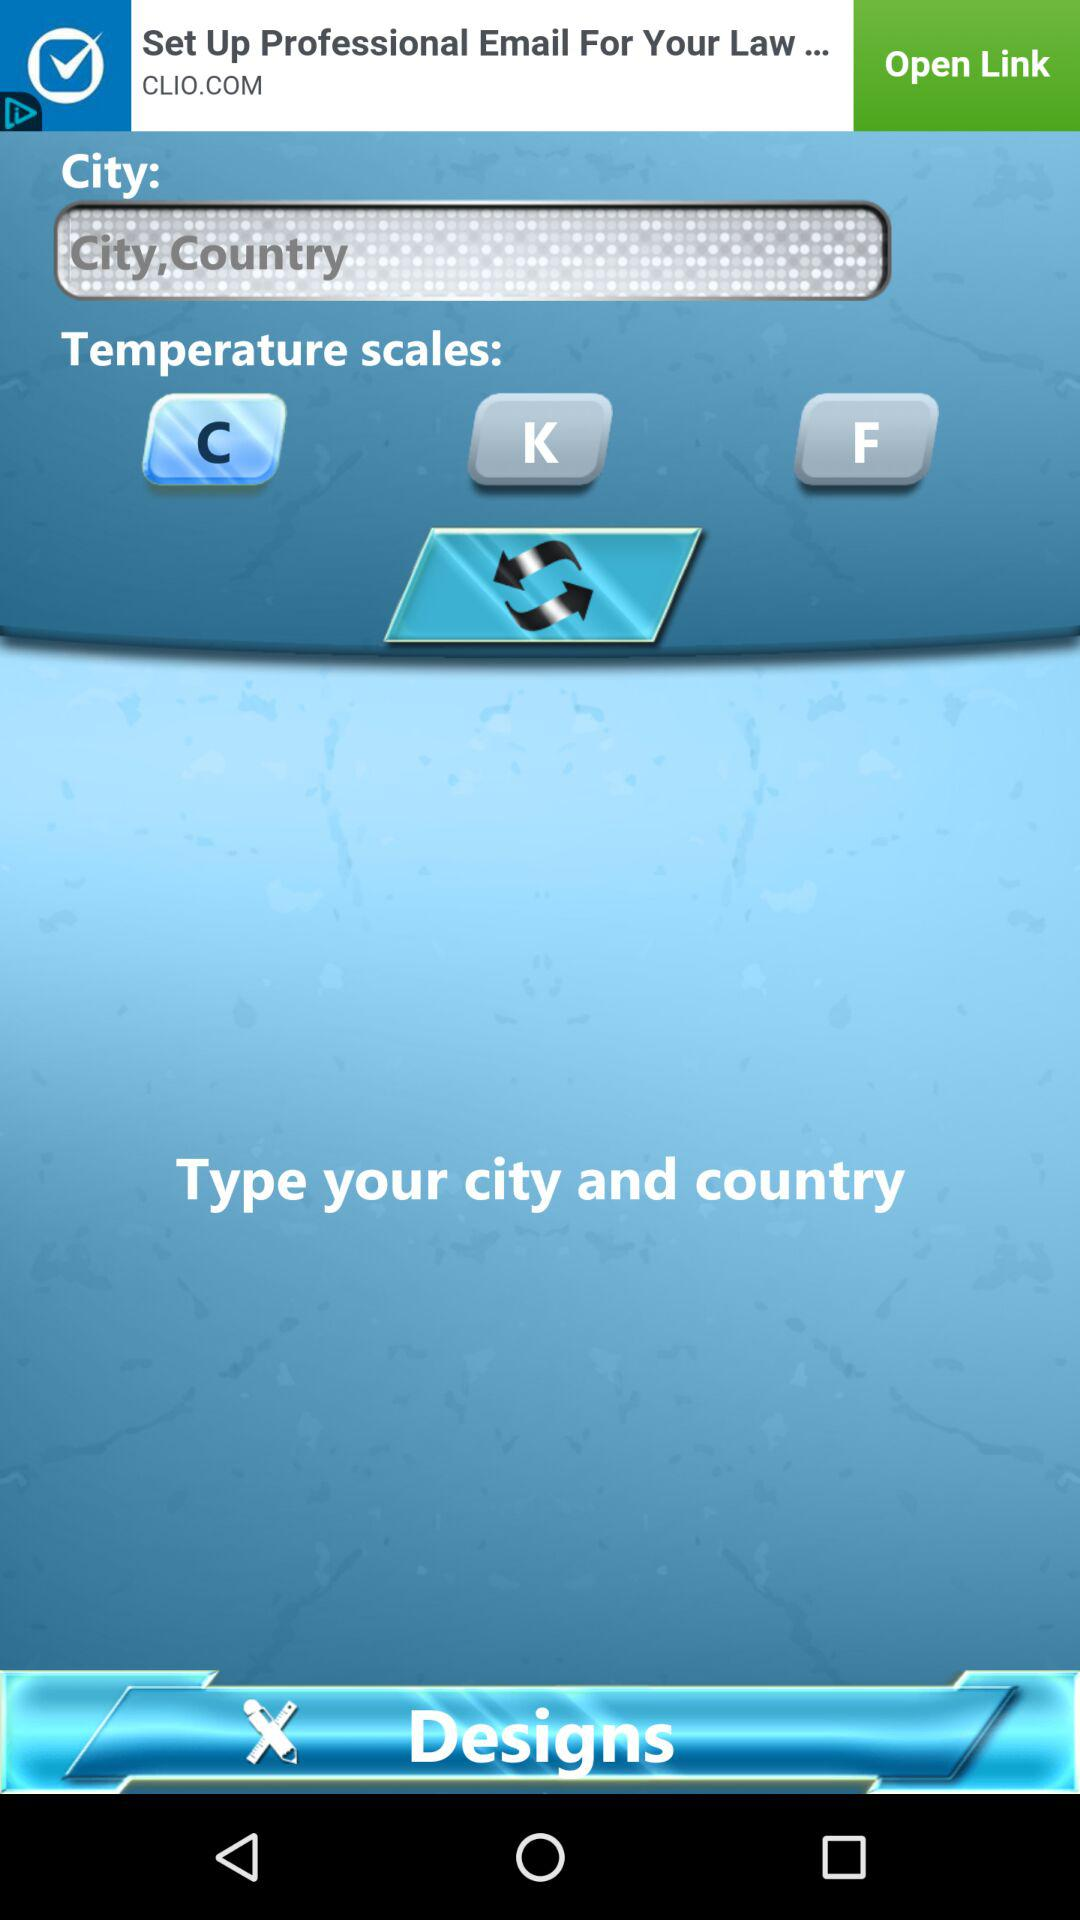Which "Temperature scales" is selected? The selected "Temperature scales" is "C". 